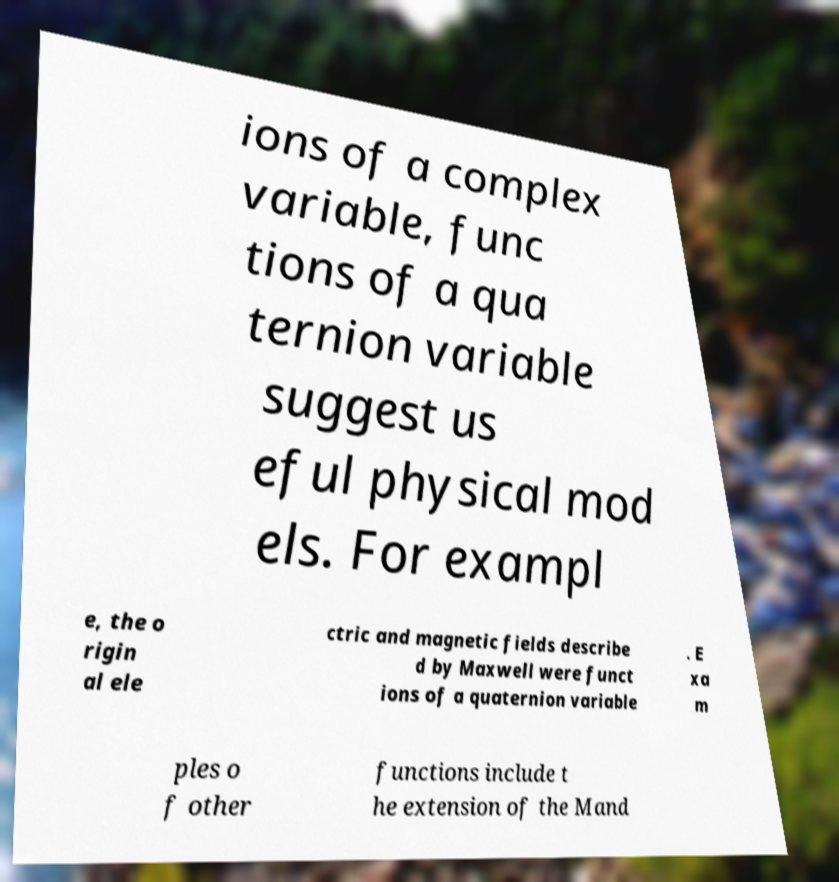Can you read and provide the text displayed in the image?This photo seems to have some interesting text. Can you extract and type it out for me? ions of a complex variable, func tions of a qua ternion variable suggest us eful physical mod els. For exampl e, the o rigin al ele ctric and magnetic fields describe d by Maxwell were funct ions of a quaternion variable . E xa m ples o f other functions include t he extension of the Mand 